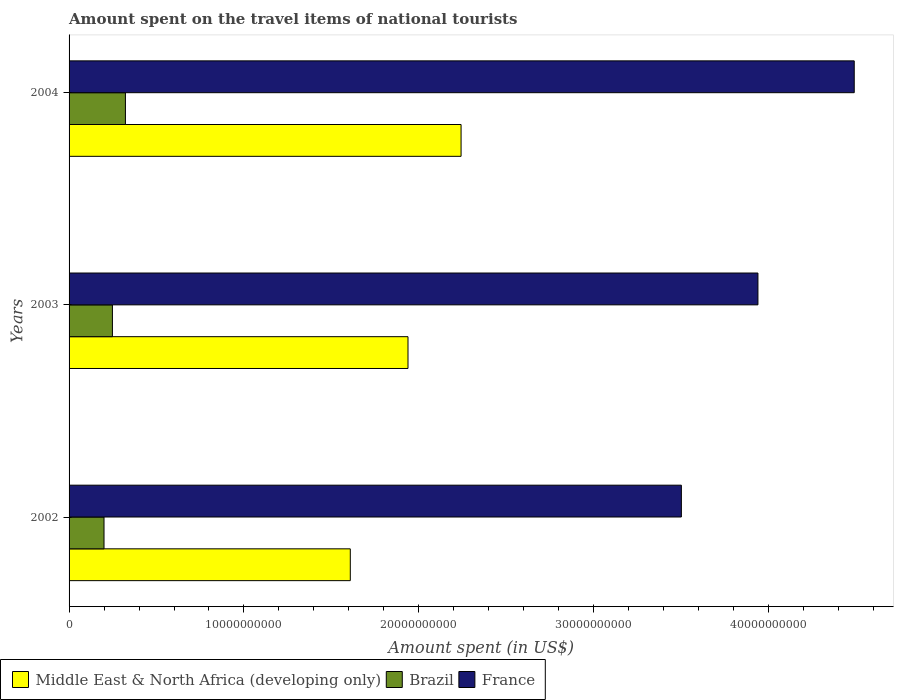How many different coloured bars are there?
Offer a very short reply. 3. How many groups of bars are there?
Your answer should be very brief. 3. Are the number of bars on each tick of the Y-axis equal?
Provide a short and direct response. Yes. How many bars are there on the 1st tick from the top?
Provide a succinct answer. 3. How many bars are there on the 3rd tick from the bottom?
Offer a very short reply. 3. What is the amount spent on the travel items of national tourists in Brazil in 2004?
Your answer should be compact. 3.22e+09. Across all years, what is the maximum amount spent on the travel items of national tourists in Middle East & North Africa (developing only)?
Your response must be concise. 2.24e+1. Across all years, what is the minimum amount spent on the travel items of national tourists in France?
Make the answer very short. 3.50e+1. In which year was the amount spent on the travel items of national tourists in Middle East & North Africa (developing only) maximum?
Keep it short and to the point. 2004. In which year was the amount spent on the travel items of national tourists in Brazil minimum?
Offer a very short reply. 2002. What is the total amount spent on the travel items of national tourists in France in the graph?
Give a very brief answer. 1.19e+11. What is the difference between the amount spent on the travel items of national tourists in Brazil in 2002 and that in 2003?
Offer a very short reply. -4.81e+08. What is the difference between the amount spent on the travel items of national tourists in Brazil in 2004 and the amount spent on the travel items of national tourists in Middle East & North Africa (developing only) in 2003?
Your answer should be compact. -1.62e+1. What is the average amount spent on the travel items of national tourists in Middle East & North Africa (developing only) per year?
Offer a terse response. 1.93e+1. In the year 2003, what is the difference between the amount spent on the travel items of national tourists in France and amount spent on the travel items of national tourists in Brazil?
Provide a succinct answer. 3.69e+1. In how many years, is the amount spent on the travel items of national tourists in Middle East & North Africa (developing only) greater than 40000000000 US$?
Your response must be concise. 0. What is the ratio of the amount spent on the travel items of national tourists in Brazil in 2002 to that in 2003?
Give a very brief answer. 0.81. What is the difference between the highest and the second highest amount spent on the travel items of national tourists in Brazil?
Give a very brief answer. 7.43e+08. What is the difference between the highest and the lowest amount spent on the travel items of national tourists in Brazil?
Give a very brief answer. 1.22e+09. In how many years, is the amount spent on the travel items of national tourists in Brazil greater than the average amount spent on the travel items of national tourists in Brazil taken over all years?
Keep it short and to the point. 1. What does the 2nd bar from the top in 2002 represents?
Your answer should be compact. Brazil. What does the 3rd bar from the bottom in 2003 represents?
Your response must be concise. France. Is it the case that in every year, the sum of the amount spent on the travel items of national tourists in France and amount spent on the travel items of national tourists in Brazil is greater than the amount spent on the travel items of national tourists in Middle East & North Africa (developing only)?
Keep it short and to the point. Yes. Are all the bars in the graph horizontal?
Offer a terse response. Yes. What is the difference between two consecutive major ticks on the X-axis?
Make the answer very short. 1.00e+1. Does the graph contain any zero values?
Give a very brief answer. No. Where does the legend appear in the graph?
Offer a very short reply. Bottom left. How many legend labels are there?
Offer a very short reply. 3. What is the title of the graph?
Keep it short and to the point. Amount spent on the travel items of national tourists. Does "Kosovo" appear as one of the legend labels in the graph?
Keep it short and to the point. No. What is the label or title of the X-axis?
Ensure brevity in your answer.  Amount spent (in US$). What is the Amount spent (in US$) of Middle East & North Africa (developing only) in 2002?
Ensure brevity in your answer.  1.61e+1. What is the Amount spent (in US$) of Brazil in 2002?
Your answer should be compact. 2.00e+09. What is the Amount spent (in US$) in France in 2002?
Ensure brevity in your answer.  3.50e+1. What is the Amount spent (in US$) in Middle East & North Africa (developing only) in 2003?
Your answer should be compact. 1.94e+1. What is the Amount spent (in US$) of Brazil in 2003?
Make the answer very short. 2.48e+09. What is the Amount spent (in US$) in France in 2003?
Offer a terse response. 3.94e+1. What is the Amount spent (in US$) in Middle East & North Africa (developing only) in 2004?
Offer a very short reply. 2.24e+1. What is the Amount spent (in US$) of Brazil in 2004?
Offer a very short reply. 3.22e+09. What is the Amount spent (in US$) of France in 2004?
Your answer should be very brief. 4.49e+1. Across all years, what is the maximum Amount spent (in US$) in Middle East & North Africa (developing only)?
Offer a terse response. 2.24e+1. Across all years, what is the maximum Amount spent (in US$) of Brazil?
Make the answer very short. 3.22e+09. Across all years, what is the maximum Amount spent (in US$) of France?
Ensure brevity in your answer.  4.49e+1. Across all years, what is the minimum Amount spent (in US$) of Middle East & North Africa (developing only)?
Keep it short and to the point. 1.61e+1. Across all years, what is the minimum Amount spent (in US$) in Brazil?
Provide a succinct answer. 2.00e+09. Across all years, what is the minimum Amount spent (in US$) in France?
Ensure brevity in your answer.  3.50e+1. What is the total Amount spent (in US$) of Middle East & North Africa (developing only) in the graph?
Your response must be concise. 5.79e+1. What is the total Amount spent (in US$) in Brazil in the graph?
Give a very brief answer. 7.70e+09. What is the total Amount spent (in US$) in France in the graph?
Your response must be concise. 1.19e+11. What is the difference between the Amount spent (in US$) of Middle East & North Africa (developing only) in 2002 and that in 2003?
Your answer should be compact. -3.30e+09. What is the difference between the Amount spent (in US$) in Brazil in 2002 and that in 2003?
Your answer should be very brief. -4.81e+08. What is the difference between the Amount spent (in US$) of France in 2002 and that in 2003?
Make the answer very short. -4.38e+09. What is the difference between the Amount spent (in US$) in Middle East & North Africa (developing only) in 2002 and that in 2004?
Offer a terse response. -6.33e+09. What is the difference between the Amount spent (in US$) of Brazil in 2002 and that in 2004?
Your answer should be very brief. -1.22e+09. What is the difference between the Amount spent (in US$) in France in 2002 and that in 2004?
Give a very brief answer. -9.88e+09. What is the difference between the Amount spent (in US$) of Middle East & North Africa (developing only) in 2003 and that in 2004?
Make the answer very short. -3.03e+09. What is the difference between the Amount spent (in US$) of Brazil in 2003 and that in 2004?
Provide a succinct answer. -7.43e+08. What is the difference between the Amount spent (in US$) in France in 2003 and that in 2004?
Give a very brief answer. -5.51e+09. What is the difference between the Amount spent (in US$) in Middle East & North Africa (developing only) in 2002 and the Amount spent (in US$) in Brazil in 2003?
Give a very brief answer. 1.36e+1. What is the difference between the Amount spent (in US$) of Middle East & North Africa (developing only) in 2002 and the Amount spent (in US$) of France in 2003?
Your answer should be compact. -2.33e+1. What is the difference between the Amount spent (in US$) in Brazil in 2002 and the Amount spent (in US$) in France in 2003?
Your answer should be very brief. -3.74e+1. What is the difference between the Amount spent (in US$) of Middle East & North Africa (developing only) in 2002 and the Amount spent (in US$) of Brazil in 2004?
Give a very brief answer. 1.29e+1. What is the difference between the Amount spent (in US$) of Middle East & North Africa (developing only) in 2002 and the Amount spent (in US$) of France in 2004?
Provide a short and direct response. -2.88e+1. What is the difference between the Amount spent (in US$) of Brazil in 2002 and the Amount spent (in US$) of France in 2004?
Offer a terse response. -4.29e+1. What is the difference between the Amount spent (in US$) of Middle East & North Africa (developing only) in 2003 and the Amount spent (in US$) of Brazil in 2004?
Make the answer very short. 1.62e+1. What is the difference between the Amount spent (in US$) of Middle East & North Africa (developing only) in 2003 and the Amount spent (in US$) of France in 2004?
Give a very brief answer. -2.55e+1. What is the difference between the Amount spent (in US$) of Brazil in 2003 and the Amount spent (in US$) of France in 2004?
Ensure brevity in your answer.  -4.24e+1. What is the average Amount spent (in US$) in Middle East & North Africa (developing only) per year?
Your response must be concise. 1.93e+1. What is the average Amount spent (in US$) in Brazil per year?
Make the answer very short. 2.57e+09. What is the average Amount spent (in US$) in France per year?
Your answer should be compact. 3.98e+1. In the year 2002, what is the difference between the Amount spent (in US$) of Middle East & North Africa (developing only) and Amount spent (in US$) of Brazil?
Give a very brief answer. 1.41e+1. In the year 2002, what is the difference between the Amount spent (in US$) of Middle East & North Africa (developing only) and Amount spent (in US$) of France?
Ensure brevity in your answer.  -1.89e+1. In the year 2002, what is the difference between the Amount spent (in US$) of Brazil and Amount spent (in US$) of France?
Ensure brevity in your answer.  -3.30e+1. In the year 2003, what is the difference between the Amount spent (in US$) of Middle East & North Africa (developing only) and Amount spent (in US$) of Brazil?
Offer a very short reply. 1.69e+1. In the year 2003, what is the difference between the Amount spent (in US$) of Middle East & North Africa (developing only) and Amount spent (in US$) of France?
Provide a short and direct response. -2.00e+1. In the year 2003, what is the difference between the Amount spent (in US$) in Brazil and Amount spent (in US$) in France?
Offer a very short reply. -3.69e+1. In the year 2004, what is the difference between the Amount spent (in US$) of Middle East & North Africa (developing only) and Amount spent (in US$) of Brazil?
Give a very brief answer. 1.92e+1. In the year 2004, what is the difference between the Amount spent (in US$) in Middle East & North Africa (developing only) and Amount spent (in US$) in France?
Keep it short and to the point. -2.25e+1. In the year 2004, what is the difference between the Amount spent (in US$) in Brazil and Amount spent (in US$) in France?
Ensure brevity in your answer.  -4.17e+1. What is the ratio of the Amount spent (in US$) of Middle East & North Africa (developing only) in 2002 to that in 2003?
Your answer should be compact. 0.83. What is the ratio of the Amount spent (in US$) of Brazil in 2002 to that in 2003?
Your response must be concise. 0.81. What is the ratio of the Amount spent (in US$) in France in 2002 to that in 2003?
Your answer should be very brief. 0.89. What is the ratio of the Amount spent (in US$) in Middle East & North Africa (developing only) in 2002 to that in 2004?
Your answer should be compact. 0.72. What is the ratio of the Amount spent (in US$) in Brazil in 2002 to that in 2004?
Your response must be concise. 0.62. What is the ratio of the Amount spent (in US$) of France in 2002 to that in 2004?
Offer a terse response. 0.78. What is the ratio of the Amount spent (in US$) of Middle East & North Africa (developing only) in 2003 to that in 2004?
Offer a very short reply. 0.86. What is the ratio of the Amount spent (in US$) of Brazil in 2003 to that in 2004?
Ensure brevity in your answer.  0.77. What is the ratio of the Amount spent (in US$) in France in 2003 to that in 2004?
Your answer should be very brief. 0.88. What is the difference between the highest and the second highest Amount spent (in US$) of Middle East & North Africa (developing only)?
Keep it short and to the point. 3.03e+09. What is the difference between the highest and the second highest Amount spent (in US$) in Brazil?
Ensure brevity in your answer.  7.43e+08. What is the difference between the highest and the second highest Amount spent (in US$) of France?
Make the answer very short. 5.51e+09. What is the difference between the highest and the lowest Amount spent (in US$) in Middle East & North Africa (developing only)?
Offer a very short reply. 6.33e+09. What is the difference between the highest and the lowest Amount spent (in US$) of Brazil?
Provide a succinct answer. 1.22e+09. What is the difference between the highest and the lowest Amount spent (in US$) of France?
Offer a terse response. 9.88e+09. 